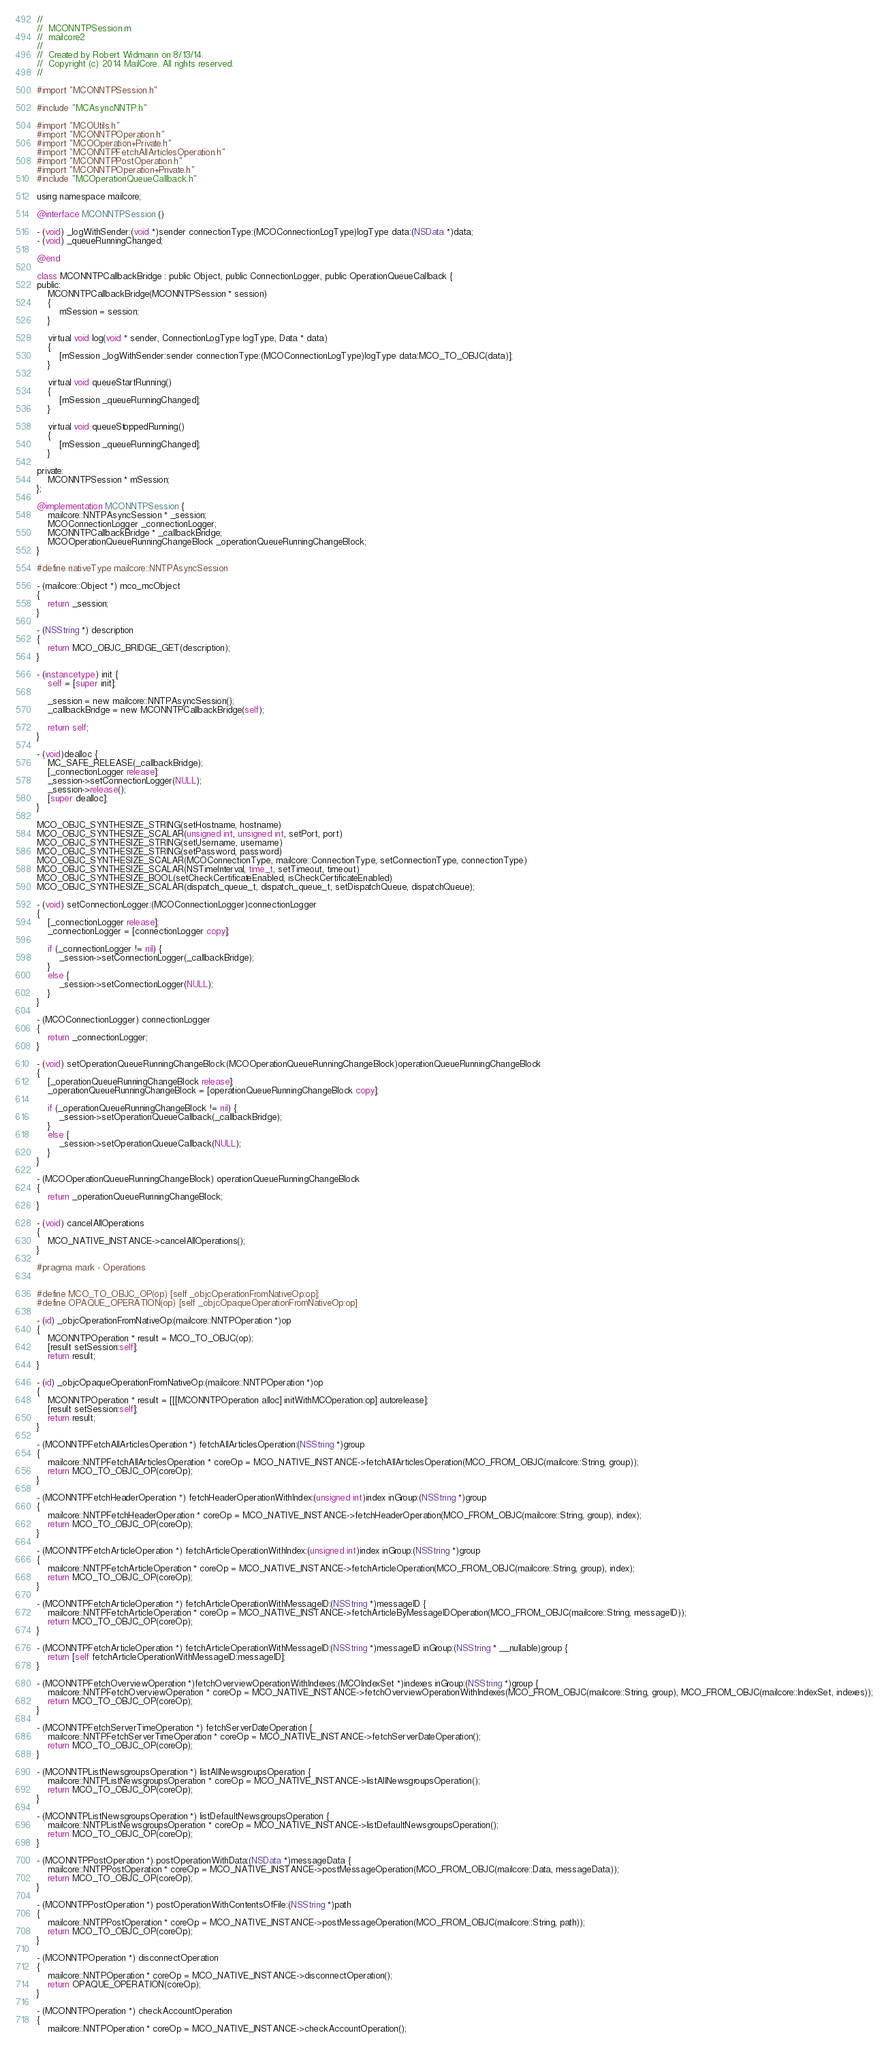<code> <loc_0><loc_0><loc_500><loc_500><_ObjectiveC_>//
//  MCONNTPSession.m
//  mailcore2
//
//  Created by Robert Widmann on 8/13/14.
//  Copyright (c) 2014 MailCore. All rights reserved.
//

#import "MCONNTPSession.h"

#include "MCAsyncNNTP.h"

#import "MCOUtils.h"
#import "MCONNTPOperation.h"
#import "MCOOperation+Private.h"
#import "MCONNTPFetchAllArticlesOperation.h"
#import "MCONNTPPostOperation.h"
#import "MCONNTPOperation+Private.h"
#include "MCOperationQueueCallback.h"

using namespace mailcore;

@interface MCONNTPSession ()

- (void) _logWithSender:(void *)sender connectionType:(MCOConnectionLogType)logType data:(NSData *)data;
- (void) _queueRunningChanged;

@end

class MCONNTPCallbackBridge : public Object, public ConnectionLogger, public OperationQueueCallback {
public:
    MCONNTPCallbackBridge(MCONNTPSession * session)
    {
        mSession = session;
    }
    
    virtual void log(void * sender, ConnectionLogType logType, Data * data)
    {
        [mSession _logWithSender:sender connectionType:(MCOConnectionLogType)logType data:MCO_TO_OBJC(data)];
    }

    virtual void queueStartRunning()
    {
        [mSession _queueRunningChanged];
    }

    virtual void queueStoppedRunning()
    {
        [mSession _queueRunningChanged];
    }

private:
    MCONNTPSession * mSession;
};

@implementation MCONNTPSession {
    mailcore::NNTPAsyncSession * _session;
    MCOConnectionLogger _connectionLogger;
    MCONNTPCallbackBridge * _callbackBridge;
    MCOOperationQueueRunningChangeBlock _operationQueueRunningChangeBlock;
}

#define nativeType mailcore::NNTPAsyncSession

- (mailcore::Object *) mco_mcObject
{
    return _session;
}

- (NSString *) description
{
    return MCO_OBJC_BRIDGE_GET(description);
}

- (instancetype) init {
    self = [super init];
    
    _session = new mailcore::NNTPAsyncSession();
    _callbackBridge = new MCONNTPCallbackBridge(self);
    
    return self;
}

- (void)dealloc {
    MC_SAFE_RELEASE(_callbackBridge);
    [_connectionLogger release];
    _session->setConnectionLogger(NULL);
    _session->release();
    [super dealloc];
}

MCO_OBJC_SYNTHESIZE_STRING(setHostname, hostname)
MCO_OBJC_SYNTHESIZE_SCALAR(unsigned int, unsigned int, setPort, port)
MCO_OBJC_SYNTHESIZE_STRING(setUsername, username)
MCO_OBJC_SYNTHESIZE_STRING(setPassword, password)
MCO_OBJC_SYNTHESIZE_SCALAR(MCOConnectionType, mailcore::ConnectionType, setConnectionType, connectionType)
MCO_OBJC_SYNTHESIZE_SCALAR(NSTimeInterval, time_t, setTimeout, timeout)
MCO_OBJC_SYNTHESIZE_BOOL(setCheckCertificateEnabled, isCheckCertificateEnabled)
MCO_OBJC_SYNTHESIZE_SCALAR(dispatch_queue_t, dispatch_queue_t, setDispatchQueue, dispatchQueue);

- (void) setConnectionLogger:(MCOConnectionLogger)connectionLogger
{
    [_connectionLogger release];
    _connectionLogger = [connectionLogger copy];
    
    if (_connectionLogger != nil) {
        _session->setConnectionLogger(_callbackBridge);
    }
    else {
        _session->setConnectionLogger(NULL);
    }
}

- (MCOConnectionLogger) connectionLogger
{
    return _connectionLogger;
}

- (void) setOperationQueueRunningChangeBlock:(MCOOperationQueueRunningChangeBlock)operationQueueRunningChangeBlock
{
    [_operationQueueRunningChangeBlock release];
    _operationQueueRunningChangeBlock = [operationQueueRunningChangeBlock copy];

    if (_operationQueueRunningChangeBlock != nil) {
        _session->setOperationQueueCallback(_callbackBridge);
    }
    else {
        _session->setOperationQueueCallback(NULL);
    }
}

- (MCOOperationQueueRunningChangeBlock) operationQueueRunningChangeBlock
{
    return _operationQueueRunningChangeBlock;
}

- (void) cancelAllOperations
{
    MCO_NATIVE_INSTANCE->cancelAllOperations();
}

#pragma mark - Operations


#define MCO_TO_OBJC_OP(op) [self _objcOperationFromNativeOp:op];
#define OPAQUE_OPERATION(op) [self _objcOpaqueOperationFromNativeOp:op]

- (id) _objcOperationFromNativeOp:(mailcore::NNTPOperation *)op
{
    MCONNTPOperation * result = MCO_TO_OBJC(op);
    [result setSession:self];
    return result;
}

- (id) _objcOpaqueOperationFromNativeOp:(mailcore::NNTPOperation *)op
{
    MCONNTPOperation * result = [[[MCONNTPOperation alloc] initWithMCOperation:op] autorelease];
    [result setSession:self];
    return result;
}

- (MCONNTPFetchAllArticlesOperation *) fetchAllArticlesOperation:(NSString *)group
{
    mailcore::NNTPFetchAllArticlesOperation * coreOp = MCO_NATIVE_INSTANCE->fetchAllArticlesOperation(MCO_FROM_OBJC(mailcore::String, group));
    return MCO_TO_OBJC_OP(coreOp);
}

- (MCONNTPFetchHeaderOperation *) fetchHeaderOperationWithIndex:(unsigned int)index inGroup:(NSString *)group
{
    mailcore::NNTPFetchHeaderOperation * coreOp = MCO_NATIVE_INSTANCE->fetchHeaderOperation(MCO_FROM_OBJC(mailcore::String, group), index);
    return MCO_TO_OBJC_OP(coreOp);
}

- (MCONNTPFetchArticleOperation *) fetchArticleOperationWithIndex:(unsigned int)index inGroup:(NSString *)group
{
    mailcore::NNTPFetchArticleOperation * coreOp = MCO_NATIVE_INSTANCE->fetchArticleOperation(MCO_FROM_OBJC(mailcore::String, group), index);
    return MCO_TO_OBJC_OP(coreOp);
}

- (MCONNTPFetchArticleOperation *) fetchArticleOperationWithMessageID:(NSString *)messageID {
    mailcore::NNTPFetchArticleOperation * coreOp = MCO_NATIVE_INSTANCE->fetchArticleByMessageIDOperation(MCO_FROM_OBJC(mailcore::String, messageID));
    return MCO_TO_OBJC_OP(coreOp);
}

- (MCONNTPFetchArticleOperation *) fetchArticleOperationWithMessageID:(NSString *)messageID inGroup:(NSString * __nullable)group {
    return [self fetchArticleOperationWithMessageID:messageID];
}

- (MCONNTPFetchOverviewOperation *)fetchOverviewOperationWithIndexes:(MCOIndexSet *)indexes inGroup:(NSString *)group {
    mailcore::NNTPFetchOverviewOperation * coreOp = MCO_NATIVE_INSTANCE->fetchOverviewOperationWithIndexes(MCO_FROM_OBJC(mailcore::String, group), MCO_FROM_OBJC(mailcore::IndexSet, indexes));
    return MCO_TO_OBJC_OP(coreOp);
}

- (MCONNTPFetchServerTimeOperation *) fetchServerDateOperation {
    mailcore::NNTPFetchServerTimeOperation * coreOp = MCO_NATIVE_INSTANCE->fetchServerDateOperation();
    return MCO_TO_OBJC_OP(coreOp);
}

- (MCONNTPListNewsgroupsOperation *) listAllNewsgroupsOperation {
    mailcore::NNTPListNewsgroupsOperation * coreOp = MCO_NATIVE_INSTANCE->listAllNewsgroupsOperation();
    return MCO_TO_OBJC_OP(coreOp);
}

- (MCONNTPListNewsgroupsOperation *) listDefaultNewsgroupsOperation {
    mailcore::NNTPListNewsgroupsOperation * coreOp = MCO_NATIVE_INSTANCE->listDefaultNewsgroupsOperation();
    return MCO_TO_OBJC_OP(coreOp);
}

- (MCONNTPPostOperation *) postOperationWithData:(NSData *)messageData {
    mailcore::NNTPPostOperation * coreOp = MCO_NATIVE_INSTANCE->postMessageOperation(MCO_FROM_OBJC(mailcore::Data, messageData));
    return MCO_TO_OBJC_OP(coreOp);
}

- (MCONNTPPostOperation *) postOperationWithContentsOfFile:(NSString *)path
{
    mailcore::NNTPPostOperation * coreOp = MCO_NATIVE_INSTANCE->postMessageOperation(MCO_FROM_OBJC(mailcore::String, path));
    return MCO_TO_OBJC_OP(coreOp);
}

- (MCONNTPOperation *) disconnectOperation
{
    mailcore::NNTPOperation * coreOp = MCO_NATIVE_INSTANCE->disconnectOperation();
    return OPAQUE_OPERATION(coreOp);
}

- (MCONNTPOperation *) checkAccountOperation
{
    mailcore::NNTPOperation * coreOp = MCO_NATIVE_INSTANCE->checkAccountOperation();</code> 